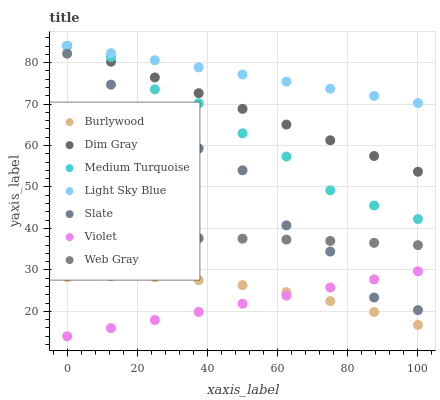Does Violet have the minimum area under the curve?
Answer yes or no. Yes. Does Light Sky Blue have the maximum area under the curve?
Answer yes or no. Yes. Does Burlywood have the minimum area under the curve?
Answer yes or no. No. Does Burlywood have the maximum area under the curve?
Answer yes or no. No. Is Violet the smoothest?
Answer yes or no. Yes. Is Slate the roughest?
Answer yes or no. Yes. Is Burlywood the smoothest?
Answer yes or no. No. Is Burlywood the roughest?
Answer yes or no. No. Does Violet have the lowest value?
Answer yes or no. Yes. Does Burlywood have the lowest value?
Answer yes or no. No. Does Medium Turquoise have the highest value?
Answer yes or no. Yes. Does Slate have the highest value?
Answer yes or no. No. Is Burlywood less than Web Gray?
Answer yes or no. Yes. Is Dim Gray greater than Violet?
Answer yes or no. Yes. Does Medium Turquoise intersect Dim Gray?
Answer yes or no. Yes. Is Medium Turquoise less than Dim Gray?
Answer yes or no. No. Is Medium Turquoise greater than Dim Gray?
Answer yes or no. No. Does Burlywood intersect Web Gray?
Answer yes or no. No. 